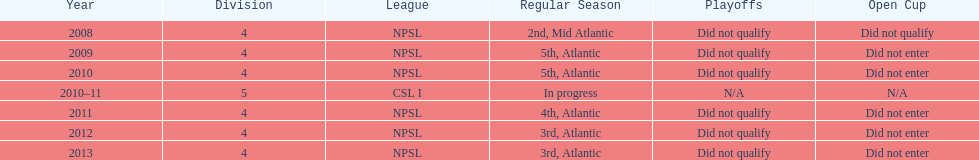What is the least ranking they attained? 5th. 